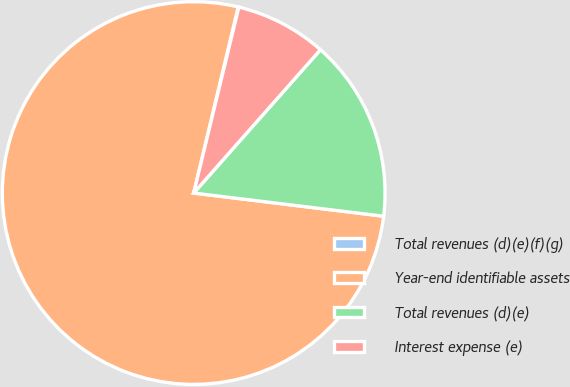Convert chart to OTSL. <chart><loc_0><loc_0><loc_500><loc_500><pie_chart><fcel>Total revenues (d)(e)(f)(g)<fcel>Year-end identifiable assets<fcel>Total revenues (d)(e)<fcel>Interest expense (e)<nl><fcel>0.06%<fcel>76.8%<fcel>15.41%<fcel>7.73%<nl></chart> 